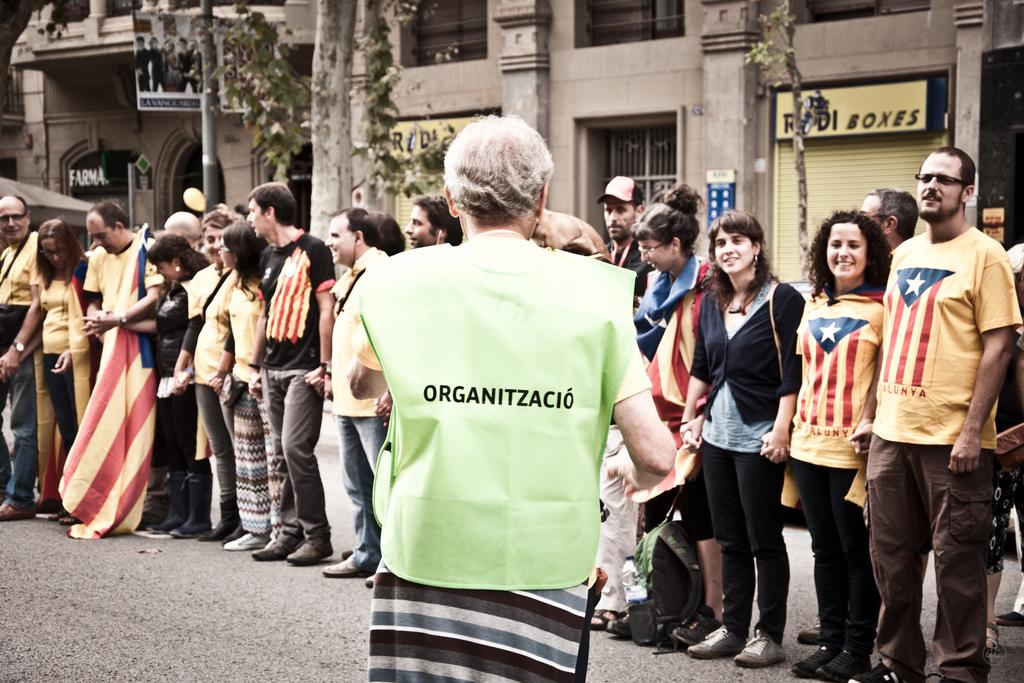What are the people in the image doing? The people in the image are standing on the road. Can you describe any specific actions or objects being held by the people? Yes, a person is holding a flag. What architectural features can be seen on the buildings in the image? The buildings have shutters and boards with text. What can be seen in the background of the image? There are trees in the background. What type of berry is being used to decorate the shutters on the buildings? There are no berries present on the shutters in the image; they are simply shutters on the buildings. Can you hear the bells ringing in the image? There are no bells present in the image, so it is not possible to hear them ringing. 